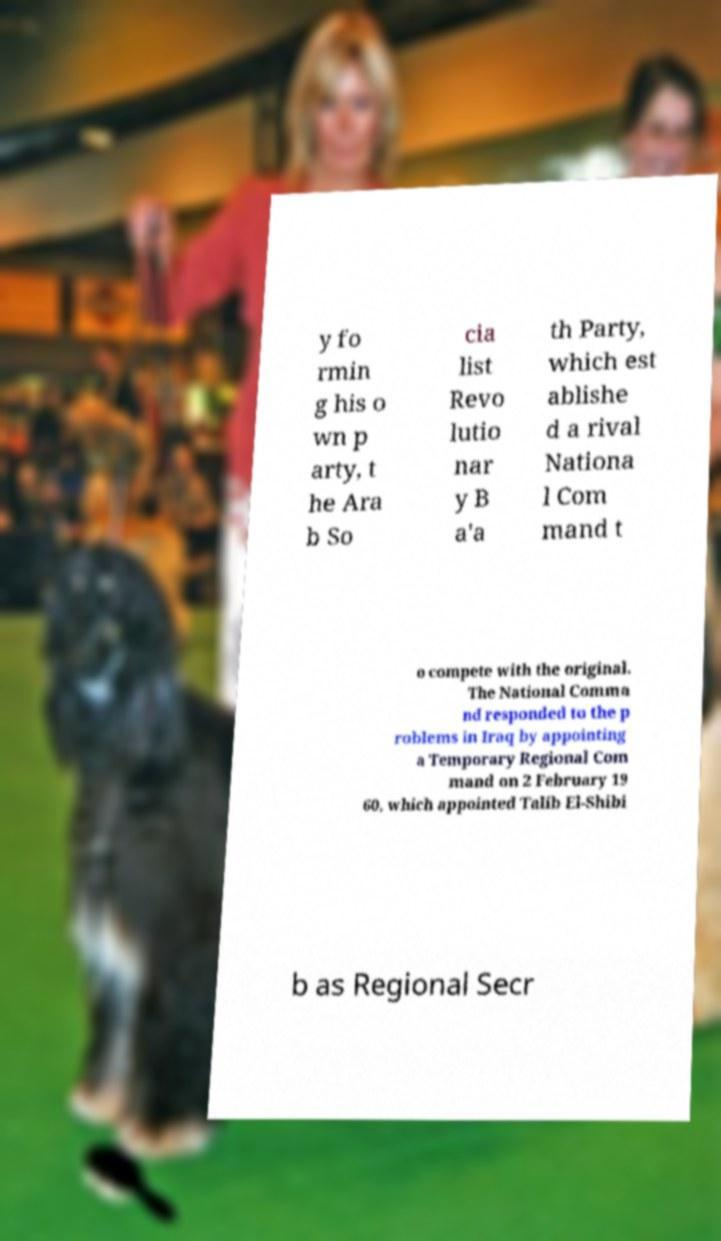Please identify and transcribe the text found in this image. y fo rmin g his o wn p arty, t he Ara b So cia list Revo lutio nar y B a'a th Party, which est ablishe d a rival Nationa l Com mand t o compete with the original. The National Comma nd responded to the p roblems in Iraq by appointing a Temporary Regional Com mand on 2 February 19 60, which appointed Talib El-Shibi b as Regional Secr 